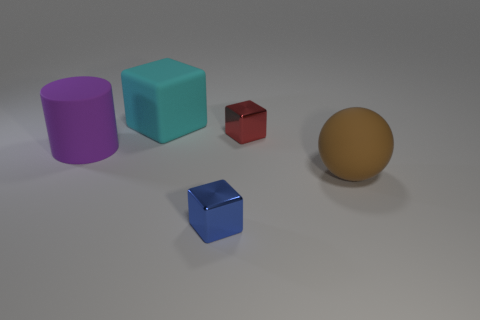Are there the same number of large cubes to the left of the cyan thing and tiny blue cubes behind the sphere? While it’s correct that there is an equal number of large cubes to the left of the cyan cube and tiny blue cubes behind the sphere, which is one each, I find it interesting that the objects are placed in a way that seems to suggest deliberate staging, with varying sizes and colors providing a visually balanced composition. 